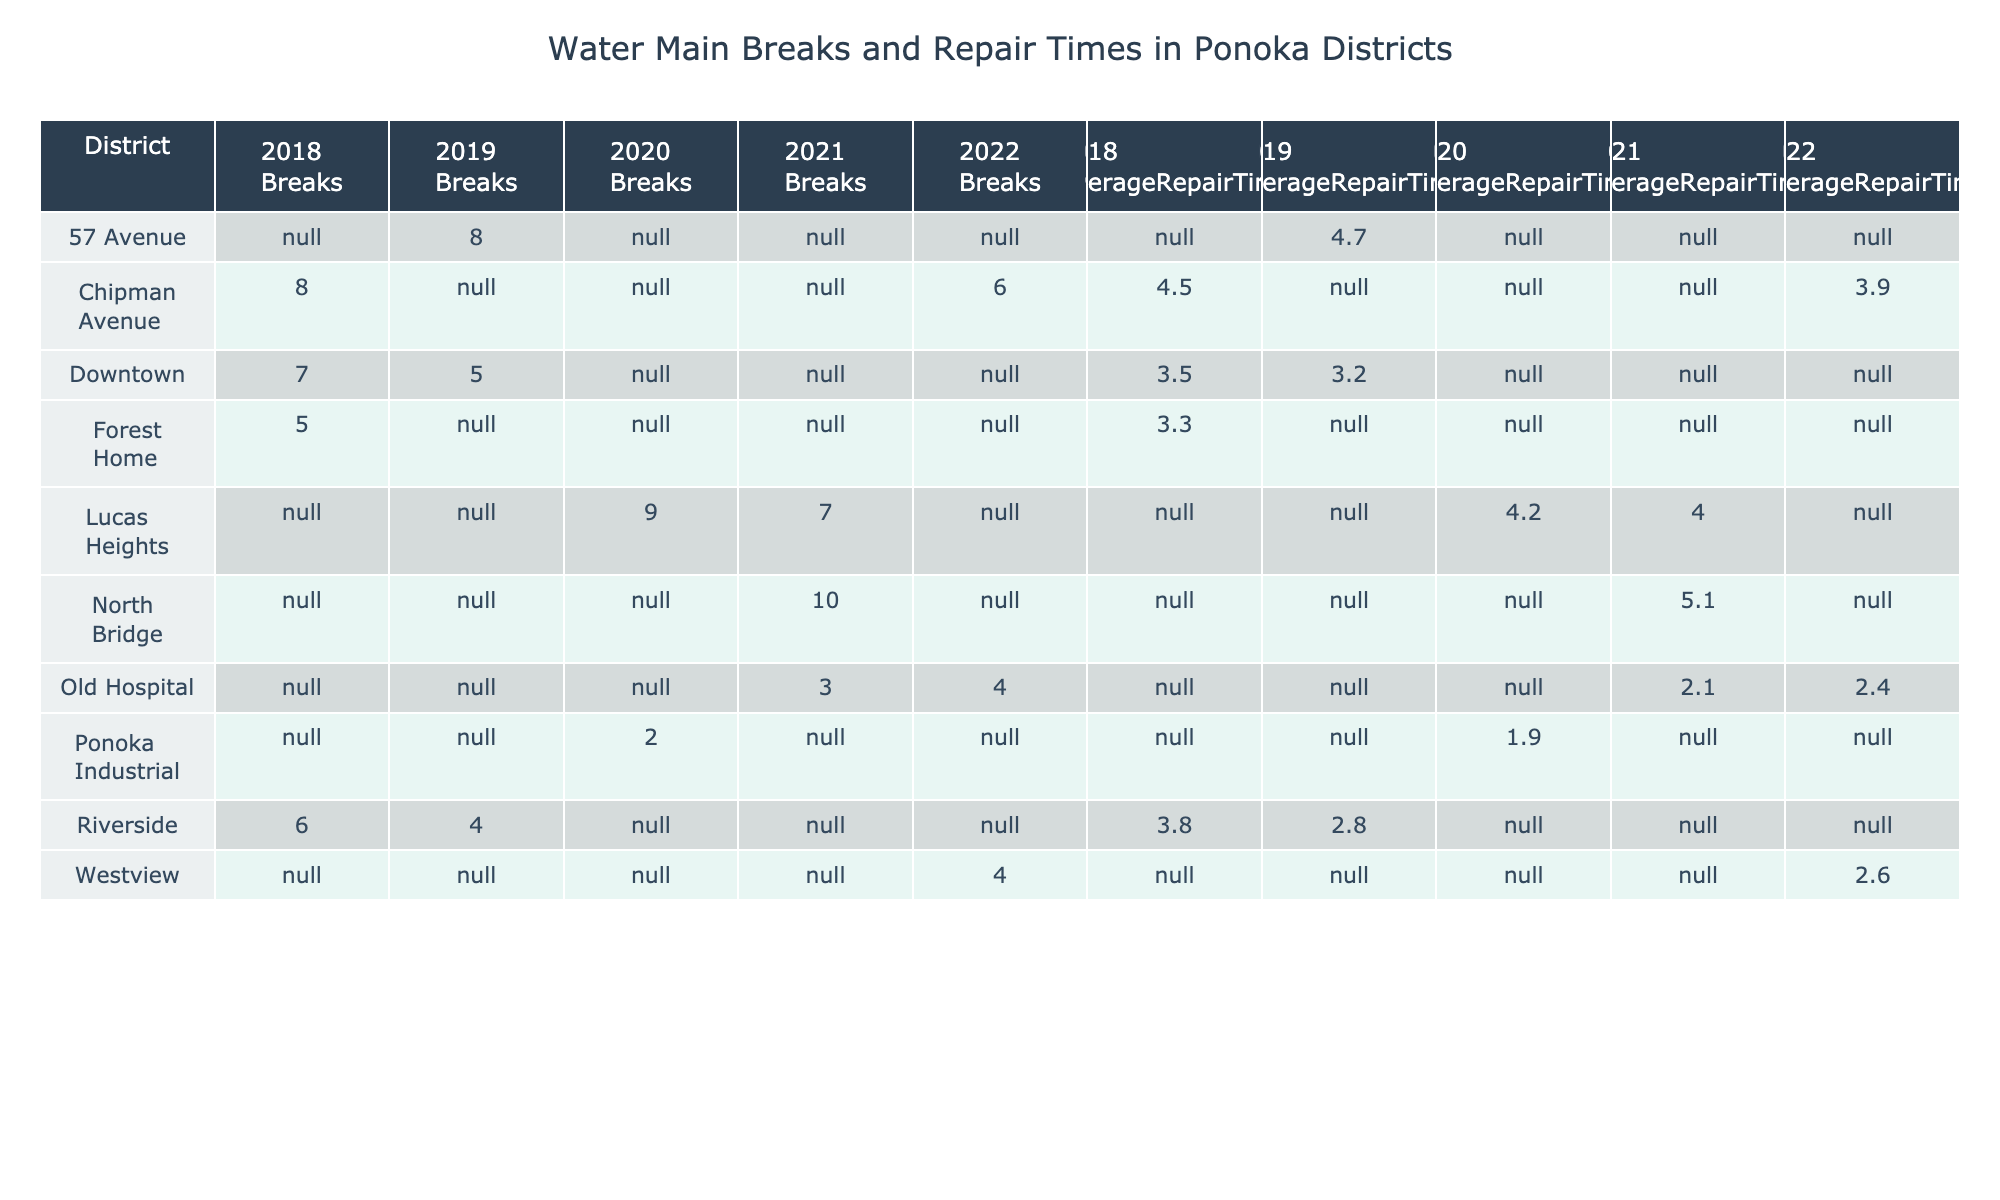What district had the highest number of breaks in 2020? In 2020, Lucas Heights had 9 breaks, which is the highest number of breaks in that year compared to other districts.
Answer: Lucas Heights Which year had the lowest average repair time and what was it? The year 2021 had the lowest average repair time of 2.1 hours in the Old Hospital district.
Answer: 2.1 hours True or false: Riverside had more breaks in 2018 than in 2019. In 2018, Riverside had 6 breaks, while in 2019, it had 4 breaks. Therefore, the statement is true.
Answer: True What is the total number of breaks across all districts in 2018? The total number of breaks in 2018 is the sum of breaks from each district: Downtown (7) + Forest Home (5) + Riverside (6) + Chipman Avenue (8) = 26.
Answer: 26 Which district experienced the longest average repair time in 2021? In 2021, North Bridge had the longest average repair time of 5.1 hours, while other districts had shorter times.
Answer: North Bridge What was the average number of breaks across all districts in 2022? The total number of breaks in 2022 is 6 (Chipman Avenue) + 4 (Old Hospital) + 4 (Westview) = 14. There are 3 districts reporting in 2022, so the average is 14/3 ≈ 4.67.
Answer: Approximately 4.67 Which district had the highest average repair time in the data? Looking at the average repair times, North Bridge in 2021 had the highest time at 5.1 hours, compared to other districts in their respective years.
Answer: North Bridge How many districts recorded breaks in both 2018 and 2022? The districts that recorded breaks in 2018 are Downtown, Forest Home, Riverside, and Chipman Avenue. For 2022, Chipman Avenue, Old Hospital, and Westview recorded breaks. Chipman Avenue is the only district common to both years, so there is 1 district.
Answer: 1 What is the difference in the number of breaks between Downtown in 2019 and Riverside in 2019? Downtown had 5 breaks in 2019 while Riverside had 4. The difference is 5 - 4 = 1.
Answer: 1 Which year had more breaks, 2019 or 2020? In 2019, the total number of breaks was Riverside (4) + Downtown (5) + 57 Avenue (8) = 17. In 2020, the total breaks were Lucas Heights (9) + Ponoka Industrial (2) = 11. Since 17 is greater than 11, 2019 had more breaks.
Answer: 2019 